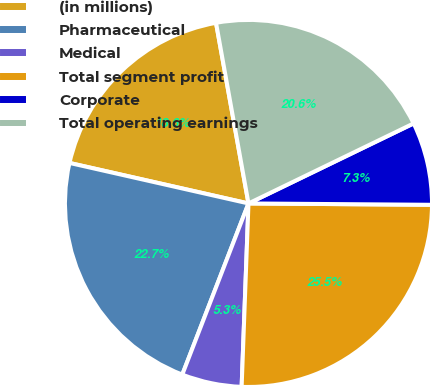Convert chart to OTSL. <chart><loc_0><loc_0><loc_500><loc_500><pie_chart><fcel>(in millions)<fcel>Pharmaceutical<fcel>Medical<fcel>Total segment profit<fcel>Corporate<fcel>Total operating earnings<nl><fcel>18.63%<fcel>22.67%<fcel>5.28%<fcel>25.48%<fcel>7.3%<fcel>20.65%<nl></chart> 